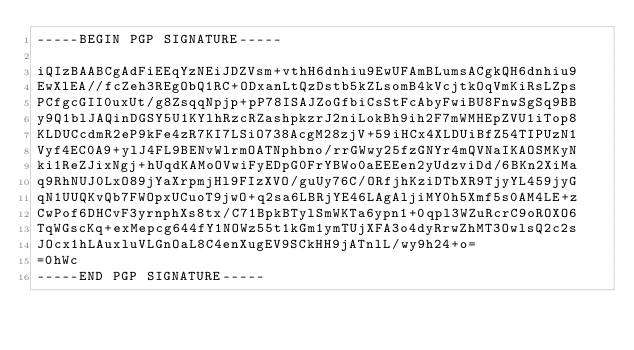Convert code to text. <code><loc_0><loc_0><loc_500><loc_500><_SML_>-----BEGIN PGP SIGNATURE-----

iQIzBAABCgAdFiEEqYzNEiJDZVsm+vthH6dnhiu9EwUFAmBLumsACgkQH6dnhiu9
EwXlEA//fcZeh3REgObQ1RC+ODxanLtQzDstb5kZLsomB4kVcjtkOqVmKiRsLZps
PCfgcGII0uxUt/g8ZsqqNpjp+pP78ISAJZoGfbiCsStFcAbyFwiBU8FnwSgSq9BB
y9Q1blJAQinDGSY5U1KYlhRzcRZashpkzrJ2niLokBh9ih2F7mWMHEpZVU1iTop8
KLDUCcdmR2eP9kFe4zR7KI7LSiO738AcgM28zjV+59iHCx4XLDUiBfZ54TIPUzN1
Vyf4EC0A9+ylJ4FL9BENvWlrmOATNphbno/rrGWwy25fzGNYr4mQVNaIKAOSMKyN
ki1ReZJixNgj+hUqdKAMoOVwiFyEDpG0FrYBWo0aEEEen2yUdzviDd/6BKn2XiMa
q9RhNUJ0LxO89jYaXrpmjHl9FIzXVO/guUy76C/ORfjhKziDTbXR9TjyYL459jyG
qN1UUQKvQb7FWOpxUCuoT9jwO+q2sa6LBRjYE46LAgAljiMY0h5Xmf5s0AM4LE+z
CwPof6DHCvF3yrnphXs8tx/C71BpkBTylSmWKTa6ypn1+0qpl3WZuRcrC9oROXO6
TqWGscKq+exMepcg644fY1NOWz55t1kGm1ymTUjXFA3o4dyRrwZhMT3OwlsQ2c2s
JOcx1hLAuxluVLGnOaL8C4enXugEV9SCkHH9jATnlL/wy9h24+o=
=0hWc
-----END PGP SIGNATURE-----
</code> 